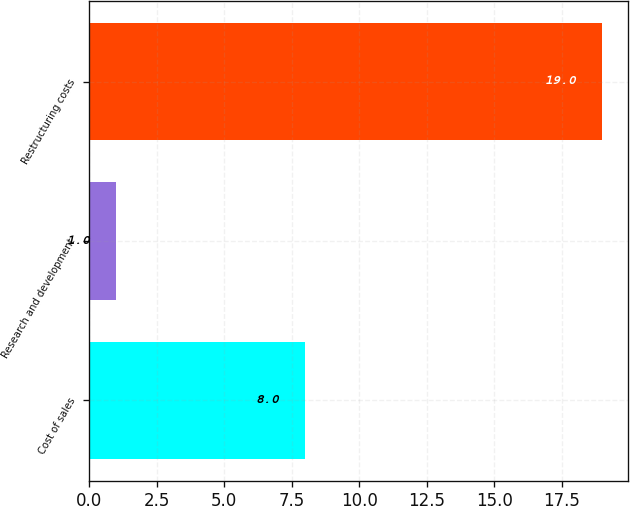Convert chart. <chart><loc_0><loc_0><loc_500><loc_500><bar_chart><fcel>Cost of sales<fcel>Research and development<fcel>Restructuring costs<nl><fcel>8<fcel>1<fcel>19<nl></chart> 